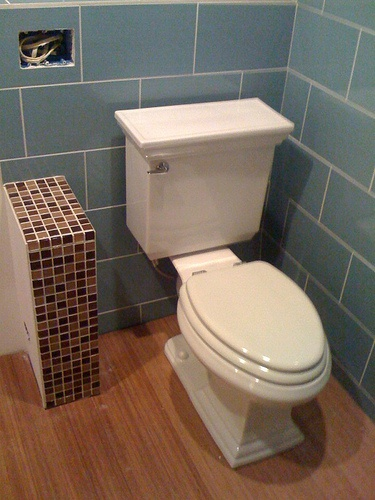Describe the objects in this image and their specific colors. I can see a toilet in darkgray, tan, and gray tones in this image. 